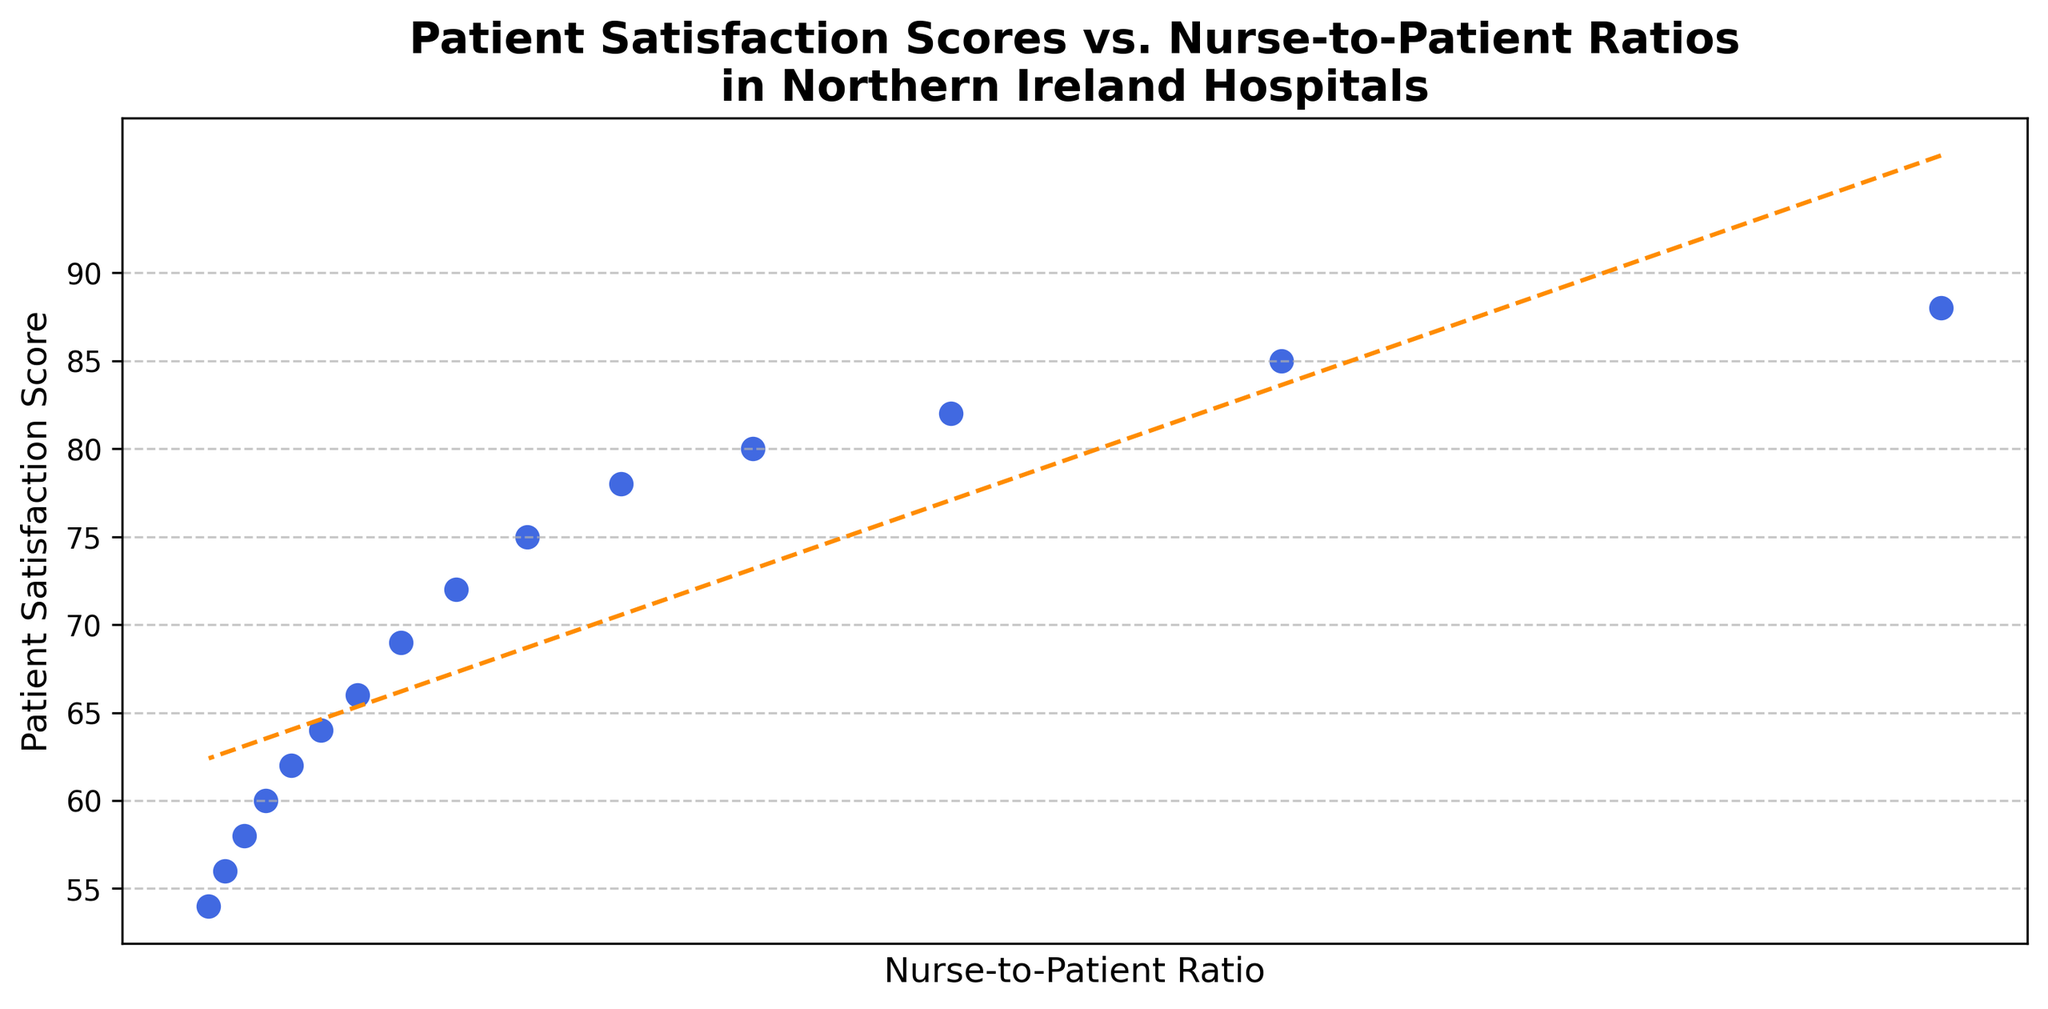What is the nurse-to-patient ratio when the patient satisfaction score is 75? Locate the point where the Patient Satisfaction Score is 75. Then check the corresponding Nurse-to-Patient Ratio on the x-axis.
Answer: 1:7 Which nurse-to-patient ratio has the highest patient satisfaction score? The highest patient satisfaction score is 88. Find the corresponding Nurse-to-Patient Ratio on the x-axis for this score.
Answer: 1:2 What is the trend in patient satisfaction scores as the nurse-to-patient ratio increases? Observe the general direction of the points and the trend line applied. As the nurse-to-patient ratio increases, the patient satisfaction scores generally decrease.
Answer: Decreasing Between ratios 1:5 and 1:10, which ratio has a higher patient satisfaction score, and by how much? Compare the scores for 1:5 (80) and 1:10 (66). Subtract the lower score from the higher one to find the difference.
Answer: 1:5 by 14 points What is the difference in patient satisfaction scores between the nurse-to-patient ratios of 1:4 and 1:12? Find the scores for both ratios: 1:4 (82) and 1:12 (62). Compute the difference: 82 - 62.
Answer: 20 points Is there any nurse-to-patient ratio where the patient satisfaction score drops below 60? If so, which one(s)? Scan through the scatter plot to identify any points below the score of 60 and note their corresponding ratios.
Answer: 1:13, 1:14, 1:15, 1:16 How does the scatter plot visually represent the trend in patient satisfaction scores? The scatter plot uses individual points for each data entry, connected by a trend line (dashed line in dark orange) to represent the overall trend.
Answer: Points & trend line If you were to average the patient satisfaction scores for nurse-to-patient ratios ranging from 1:8 to 1:12, what would be the result? Add the scores for 1:8 (72), 1:9 (69), 1:10 (66), 1:11 (64), and 1:12 (62), then divide by 5: (72+69+66+64+62)/5.
Answer: 66.6 Based on the trend line, what is the expected patient satisfaction score for a nurse-to-patient ratio of 1:17? Extend the trend line visually through the plot to approximate the score where 1:17 would fall.
Answer: Approximately 52 What is the range of patient satisfaction scores observed in the plot? Identify the highest (88) and lowest (54) scores, then calculate the range: 88 - 54.
Answer: 34 points 